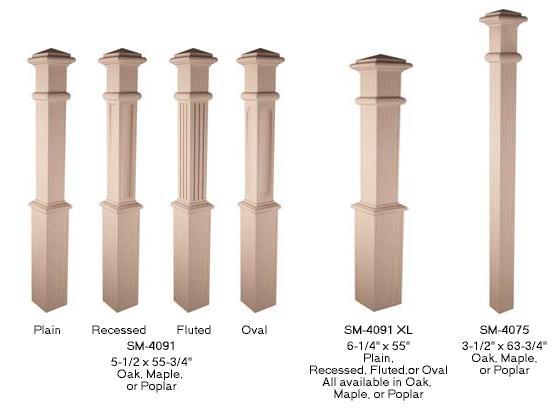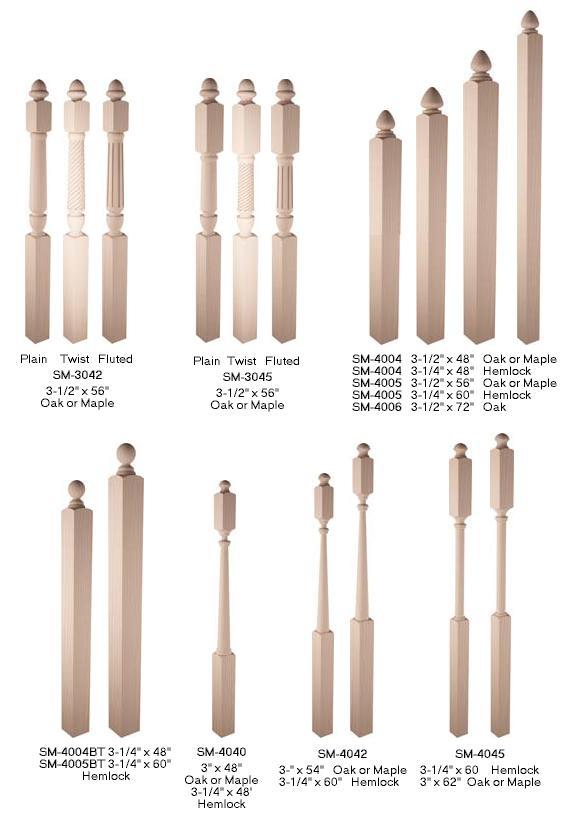The first image is the image on the left, the second image is the image on the right. Assess this claim about the two images: "Each image contains at least one row of beige posts displayed vertically with space between each one.". Correct or not? Answer yes or no. Yes. The first image is the image on the left, the second image is the image on the right. Considering the images on both sides, is "In at least one image one of the row have seven  wooden rails." valid? Answer yes or no. Yes. 